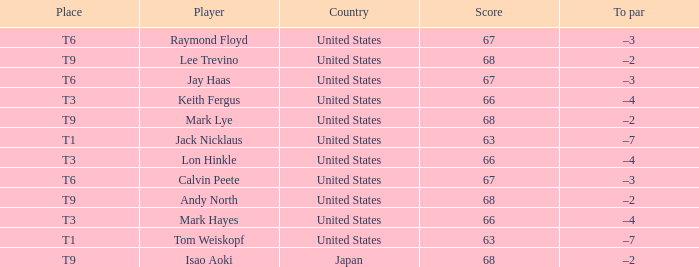What is To Par, when Place is "T9", and when Player is "Lee Trevino"? –2. 